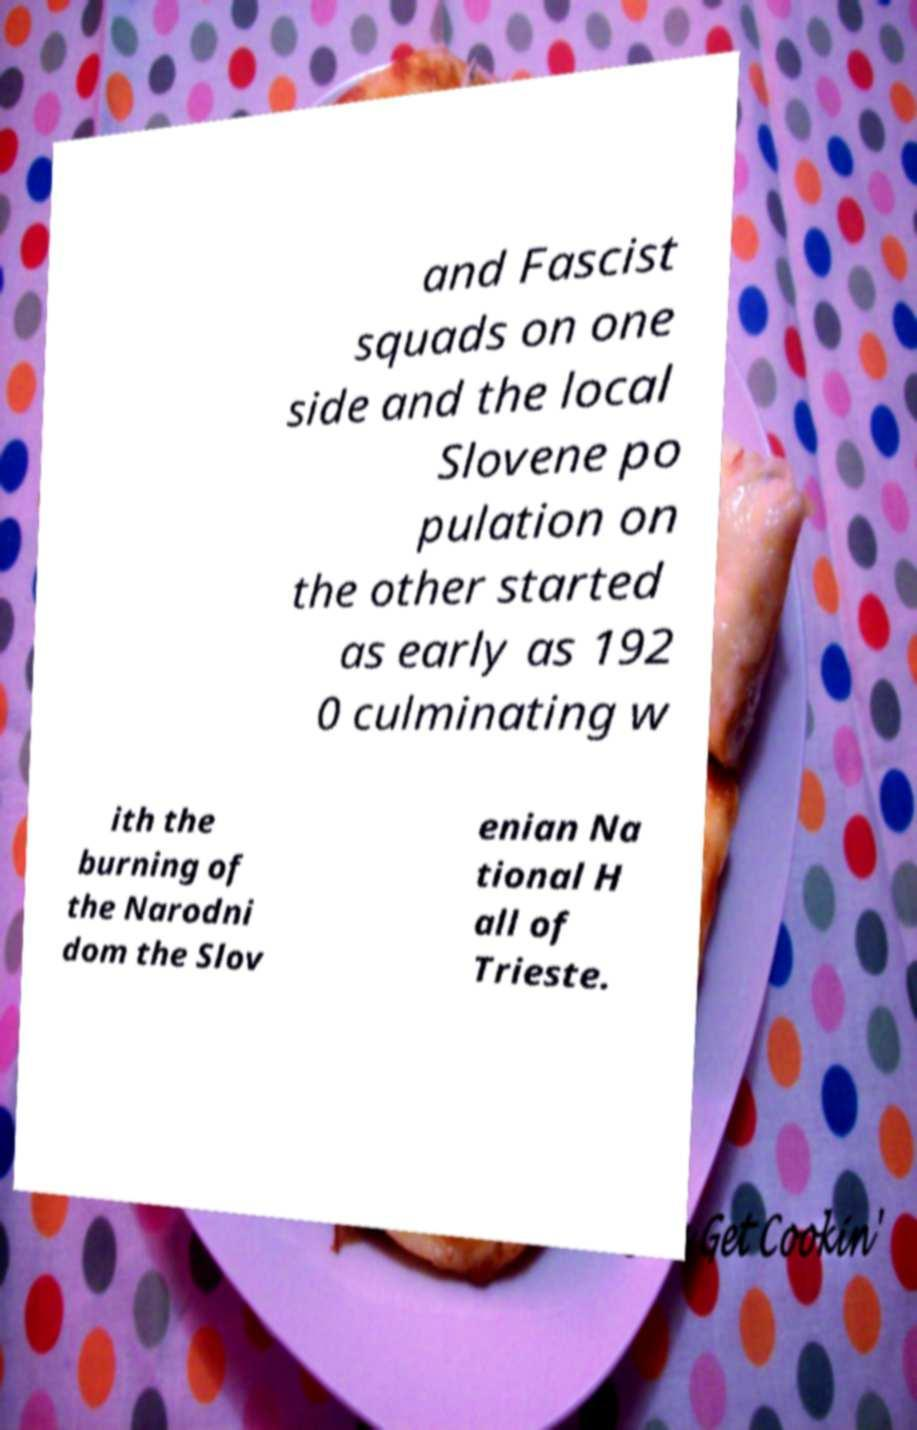There's text embedded in this image that I need extracted. Can you transcribe it verbatim? and Fascist squads on one side and the local Slovene po pulation on the other started as early as 192 0 culminating w ith the burning of the Narodni dom the Slov enian Na tional H all of Trieste. 